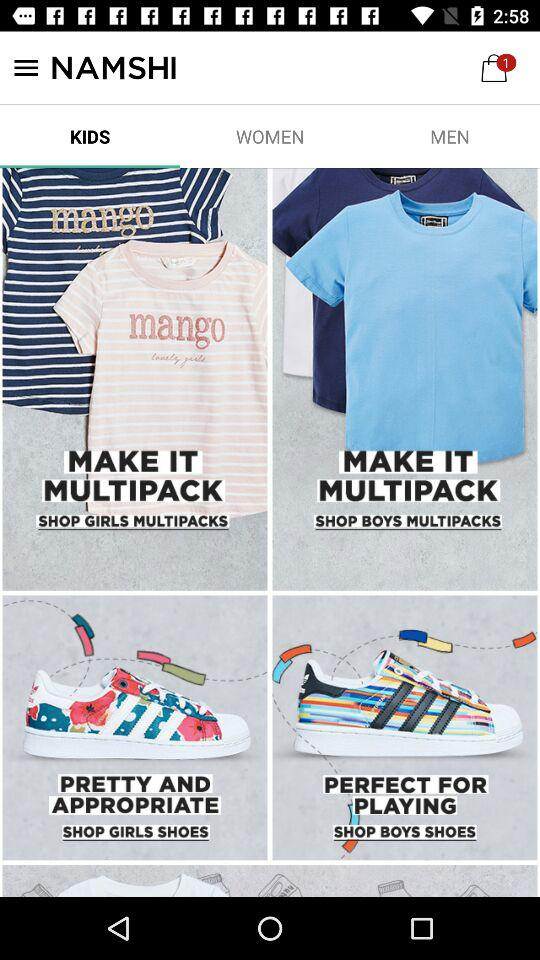How many shopping bags does the user currently have?
Answer the question using a single word or phrase. 1 